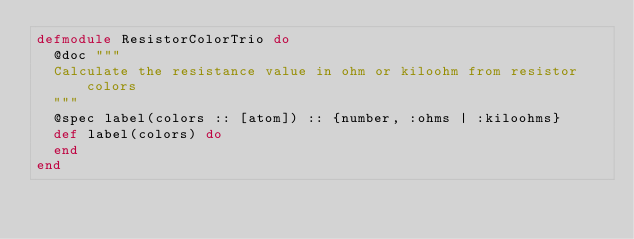Convert code to text. <code><loc_0><loc_0><loc_500><loc_500><_Elixir_>defmodule ResistorColorTrio do
  @doc """
  Calculate the resistance value in ohm or kiloohm from resistor colors
  """
  @spec label(colors :: [atom]) :: {number, :ohms | :kiloohms}
  def label(colors) do
  end
end
</code> 